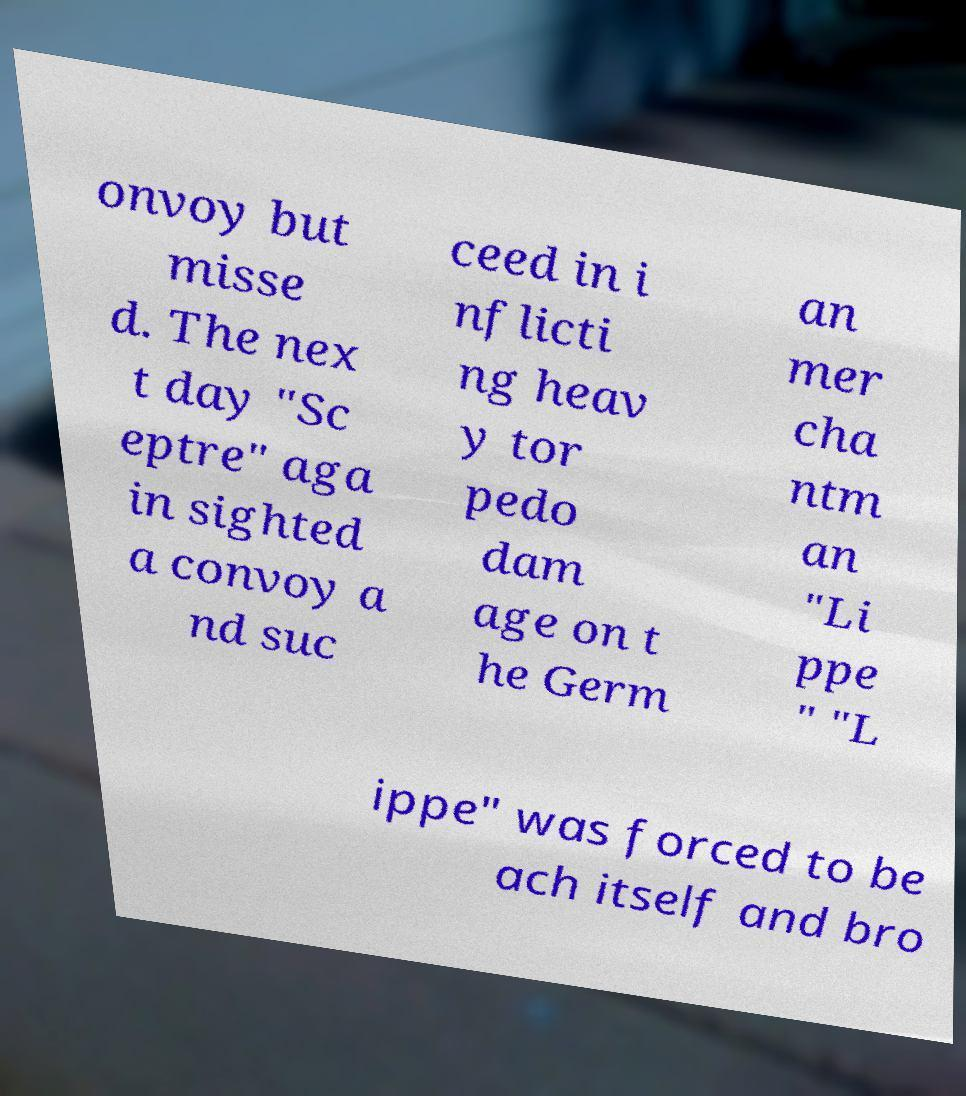Please read and relay the text visible in this image. What does it say? onvoy but misse d. The nex t day "Sc eptre" aga in sighted a convoy a nd suc ceed in i nflicti ng heav y tor pedo dam age on t he Germ an mer cha ntm an "Li ppe " "L ippe" was forced to be ach itself and bro 